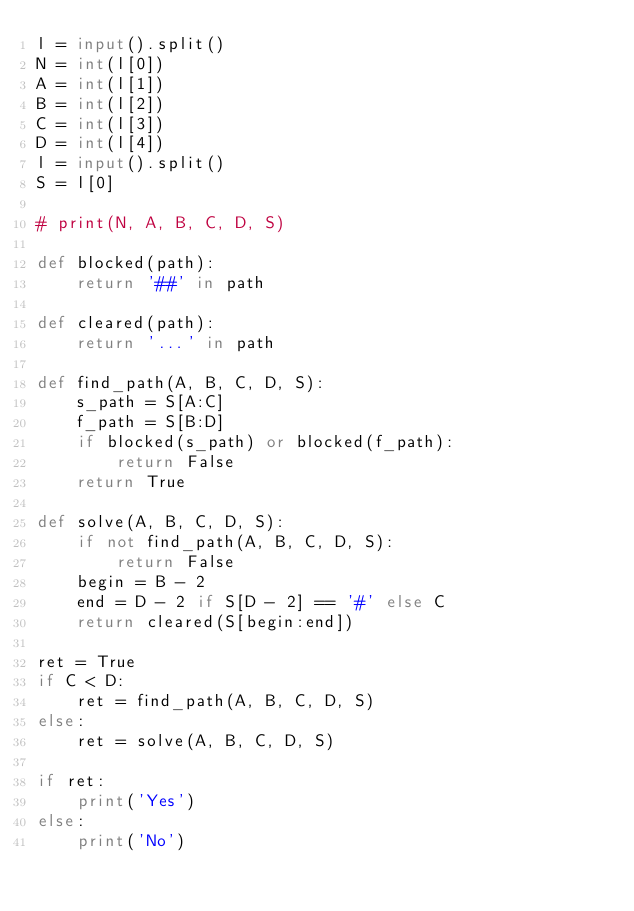Convert code to text. <code><loc_0><loc_0><loc_500><loc_500><_Python_>l = input().split()
N = int(l[0])
A = int(l[1])
B = int(l[2])
C = int(l[3])
D = int(l[4])
l = input().split()
S = l[0]

# print(N, A, B, C, D, S)

def blocked(path):
    return '##' in path

def cleared(path):
    return '...' in path

def find_path(A, B, C, D, S):
    s_path = S[A:C]
    f_path = S[B:D]
    if blocked(s_path) or blocked(f_path):
        return False
    return True

def solve(A, B, C, D, S):
    if not find_path(A, B, C, D, S):
        return False
    begin = B - 2
    end = D - 2 if S[D - 2] == '#' else C
    return cleared(S[begin:end])

ret = True
if C < D:
    ret = find_path(A, B, C, D, S)
else:
    ret = solve(A, B, C, D, S)

if ret:
    print('Yes')
else:
    print('No')
</code> 